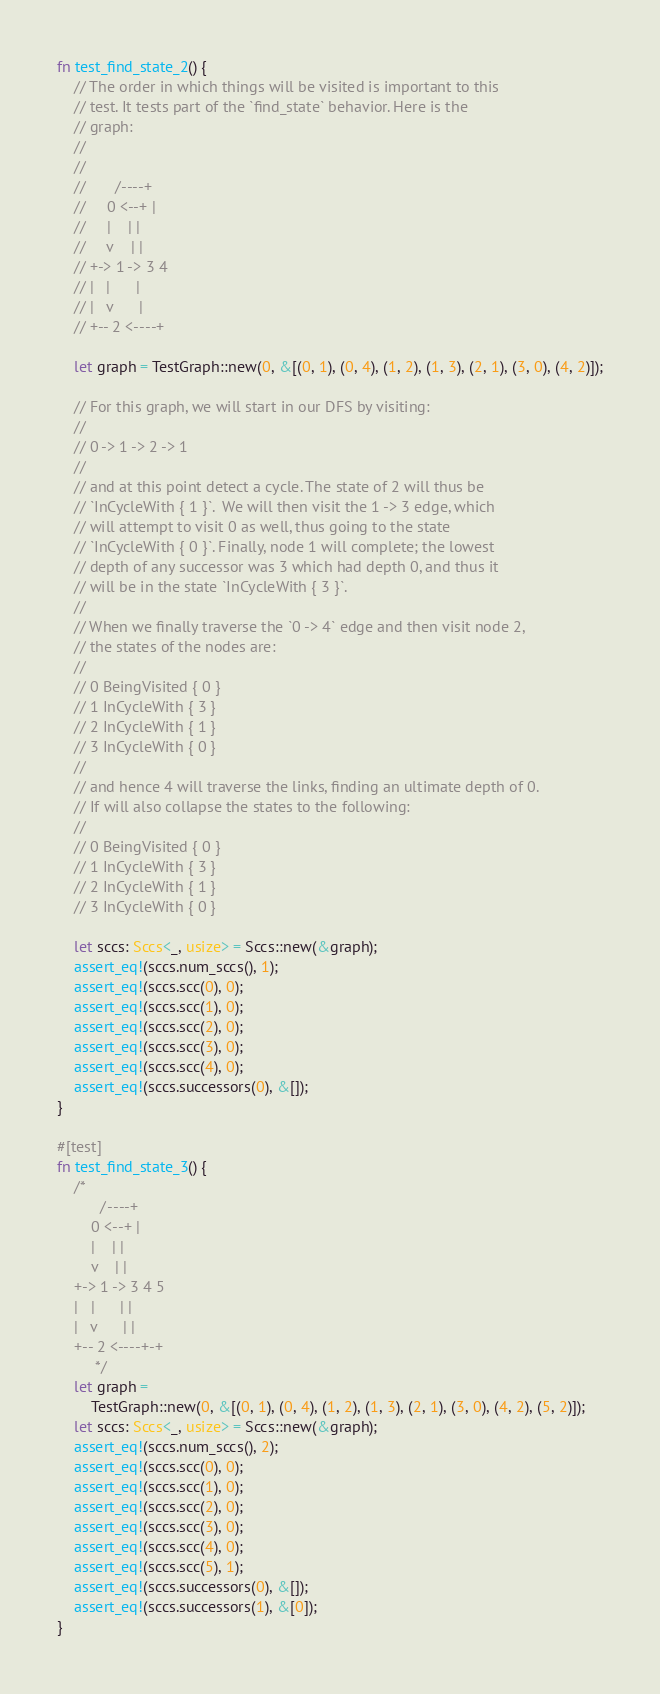Convert code to text. <code><loc_0><loc_0><loc_500><loc_500><_Rust_>fn test_find_state_2() {
    // The order in which things will be visited is important to this
    // test. It tests part of the `find_state` behavior. Here is the
    // graph:
    //
    //
    //       /----+
    //     0 <--+ |
    //     |    | |
    //     v    | |
    // +-> 1 -> 3 4
    // |   |      |
    // |   v      |
    // +-- 2 <----+

    let graph = TestGraph::new(0, &[(0, 1), (0, 4), (1, 2), (1, 3), (2, 1), (3, 0), (4, 2)]);

    // For this graph, we will start in our DFS by visiting:
    //
    // 0 -> 1 -> 2 -> 1
    //
    // and at this point detect a cycle. The state of 2 will thus be
    // `InCycleWith { 1 }`.  We will then visit the 1 -> 3 edge, which
    // will attempt to visit 0 as well, thus going to the state
    // `InCycleWith { 0 }`. Finally, node 1 will complete; the lowest
    // depth of any successor was 3 which had depth 0, and thus it
    // will be in the state `InCycleWith { 3 }`.
    //
    // When we finally traverse the `0 -> 4` edge and then visit node 2,
    // the states of the nodes are:
    //
    // 0 BeingVisited { 0 }
    // 1 InCycleWith { 3 }
    // 2 InCycleWith { 1 }
    // 3 InCycleWith { 0 }
    //
    // and hence 4 will traverse the links, finding an ultimate depth of 0.
    // If will also collapse the states to the following:
    //
    // 0 BeingVisited { 0 }
    // 1 InCycleWith { 3 }
    // 2 InCycleWith { 1 }
    // 3 InCycleWith { 0 }

    let sccs: Sccs<_, usize> = Sccs::new(&graph);
    assert_eq!(sccs.num_sccs(), 1);
    assert_eq!(sccs.scc(0), 0);
    assert_eq!(sccs.scc(1), 0);
    assert_eq!(sccs.scc(2), 0);
    assert_eq!(sccs.scc(3), 0);
    assert_eq!(sccs.scc(4), 0);
    assert_eq!(sccs.successors(0), &[]);
}

#[test]
fn test_find_state_3() {
    /*
          /----+
        0 <--+ |
        |    | |
        v    | |
    +-> 1 -> 3 4 5
    |   |      | |
    |   v      | |
    +-- 2 <----+-+
         */
    let graph =
        TestGraph::new(0, &[(0, 1), (0, 4), (1, 2), (1, 3), (2, 1), (3, 0), (4, 2), (5, 2)]);
    let sccs: Sccs<_, usize> = Sccs::new(&graph);
    assert_eq!(sccs.num_sccs(), 2);
    assert_eq!(sccs.scc(0), 0);
    assert_eq!(sccs.scc(1), 0);
    assert_eq!(sccs.scc(2), 0);
    assert_eq!(sccs.scc(3), 0);
    assert_eq!(sccs.scc(4), 0);
    assert_eq!(sccs.scc(5), 1);
    assert_eq!(sccs.successors(0), &[]);
    assert_eq!(sccs.successors(1), &[0]);
}
</code> 